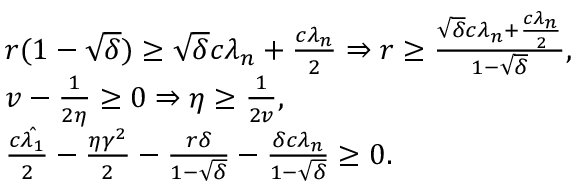Convert formula to latex. <formula><loc_0><loc_0><loc_500><loc_500>\begin{array} { r l } & { r ( 1 - \sqrt { \delta } ) \geq \sqrt { \delta } c \lambda _ { n } + \frac { c \lambda _ { n } } { 2 } \Rightarrow r \geq \frac { \sqrt { \delta } c \lambda _ { n } + \frac { c \lambda _ { n } } { 2 } } { 1 - \sqrt { \delta } } , } \\ & { v - \frac { 1 } { 2 \eta } \geq 0 \Rightarrow \eta \geq \frac { 1 } { 2 v } , } \\ & { \frac { c \hat { \lambda _ { 1 } } } { 2 } - \frac { \eta \gamma ^ { 2 } } { 2 } - \frac { r \delta } { 1 - \sqrt { \delta } } - \frac { \delta c \lambda _ { n } } { 1 - \sqrt { \delta } } \geq 0 . } \end{array}</formula> 